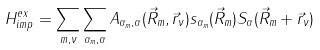<formula> <loc_0><loc_0><loc_500><loc_500>H ^ { e x } _ { i m p } = \sum _ { m , \nu } \sum _ { \alpha _ { m } , \alpha } A _ { \alpha _ { m } , \alpha } ( \vec { R } _ { m } , \vec { r } _ { \nu } ) s _ { \alpha _ { m } } ( \vec { R } _ { m } ) S _ { \alpha } ( \vec { R } _ { m } + \vec { r } _ { \nu } )</formula> 